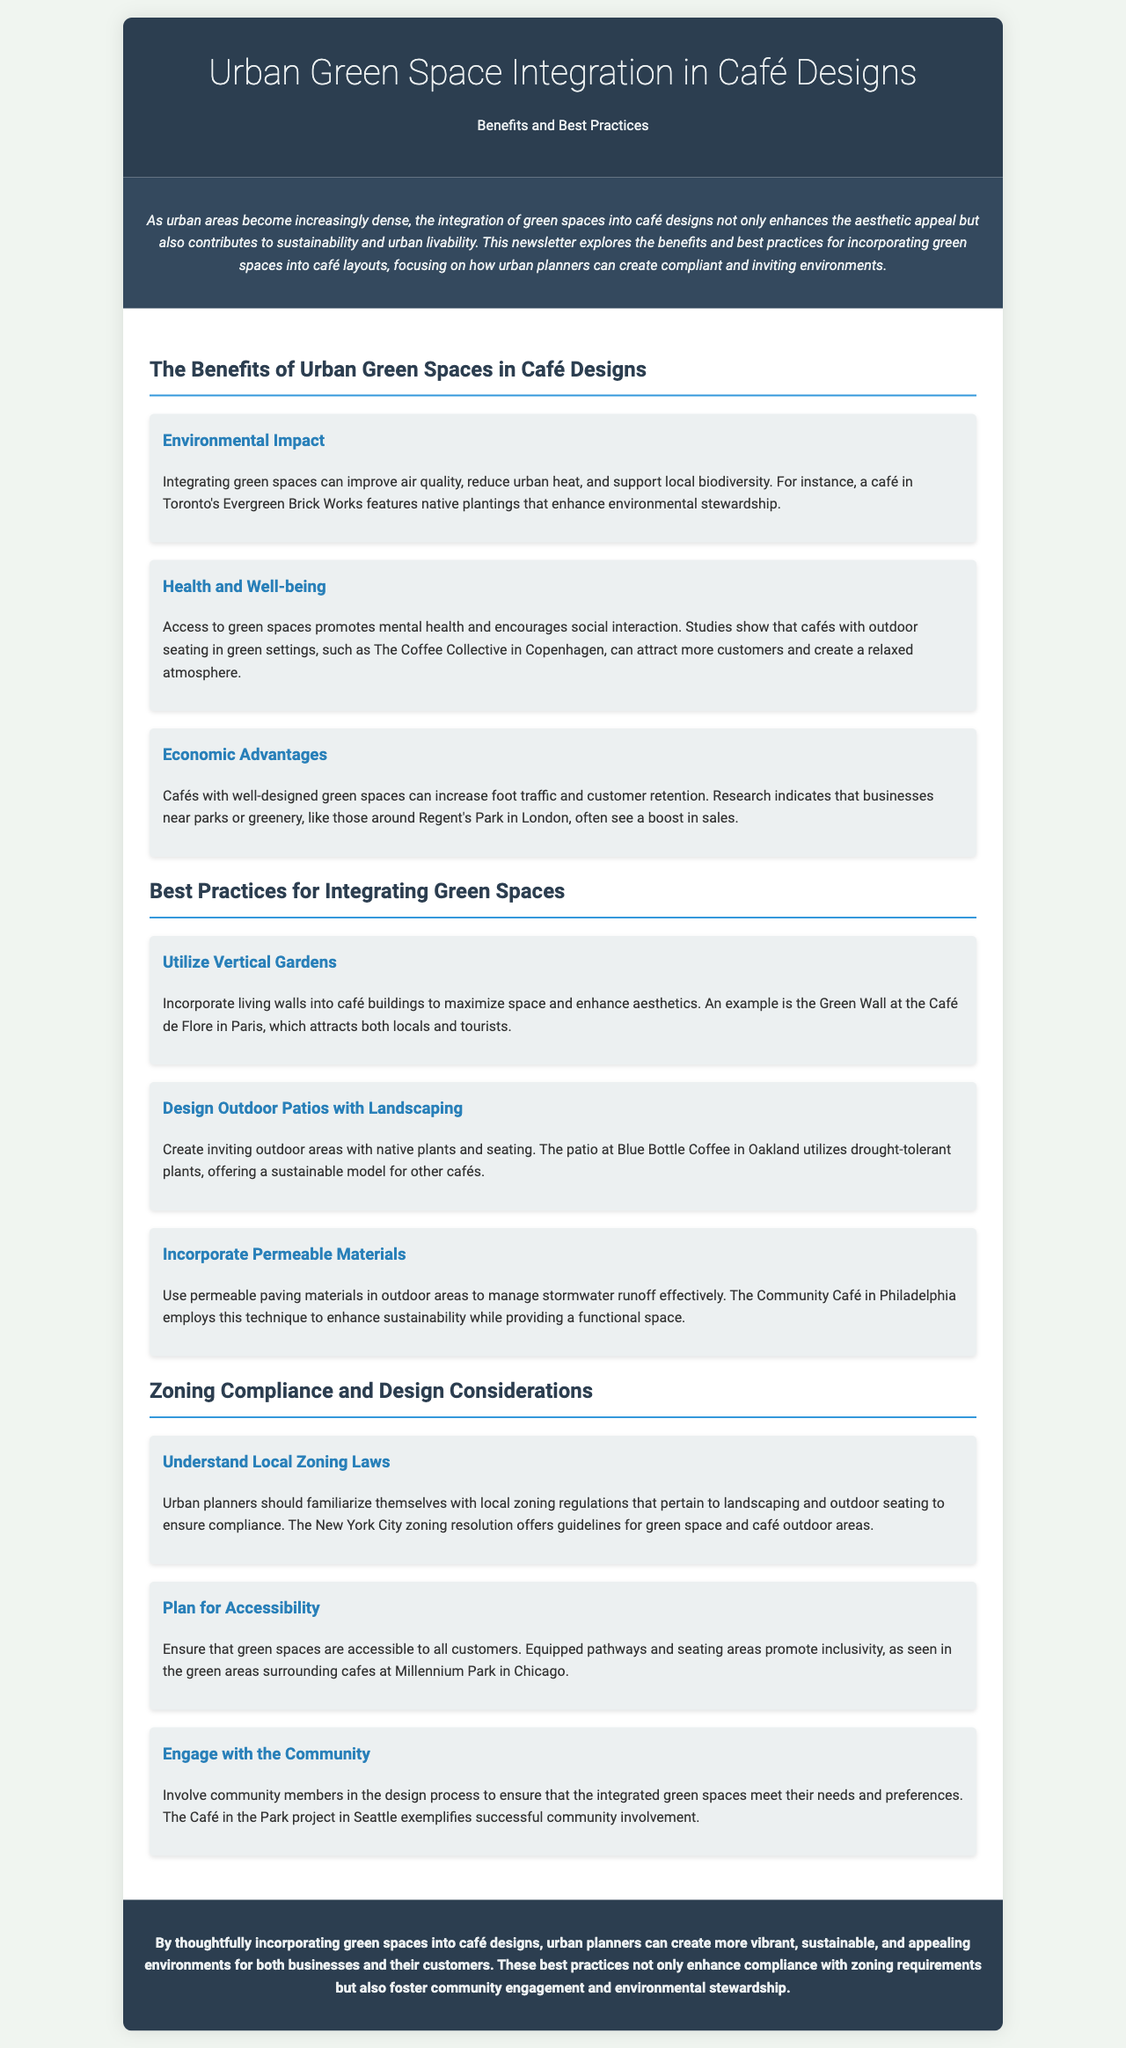what is the title of the newsletter? The title of the newsletter is presented at the top of the document and is "Urban Green Space Integration in Café Designs".
Answer: Urban Green Space Integration in Café Designs what are the three benefits of urban green spaces in café designs? The benefits listed in the newsletter include Environmental Impact, Health and Well-being, and Economic Advantages.
Answer: Environmental Impact, Health and Well-being, Economic Advantages which café features native plantings for environmental stewardship? The document mentions a café in Toronto that integrates native plantings for this purpose.
Answer: Evergreen Brick Works what type of garden is suggested to maximize space in café designs? The newsletter recommends utilizing living walls, also known as vertical gardens, to enhance aesthetics.
Answer: Vertical Gardens how can cafés increase foot traffic according to the newsletter? The newsletter indicates that cafés with well-designed green spaces can increase customer retention and foot traffic.
Answer: Well-designed green spaces what is one zoning consideration for urban planners? The newsletter emphasizes the importance of understanding local zoning laws as a consideration in café designs.
Answer: Local zoning laws which city’s zoning resolution is mentioned for guidelines on green space? The document specifically references New York City for its zoning resolution guidelines concerning green space and outdoor areas.
Answer: New York City what is a sustainable planting model used by Blue Bottle Coffee? The newsletter highlights the use of drought-tolerant plants as part of their outdoor patio landscaping.
Answer: Drought-tolerant plants how should community members be involved in café design? The newsletter recommends engaging with community members in the design process to reflect their needs and preferences.
Answer: Engage with the community 